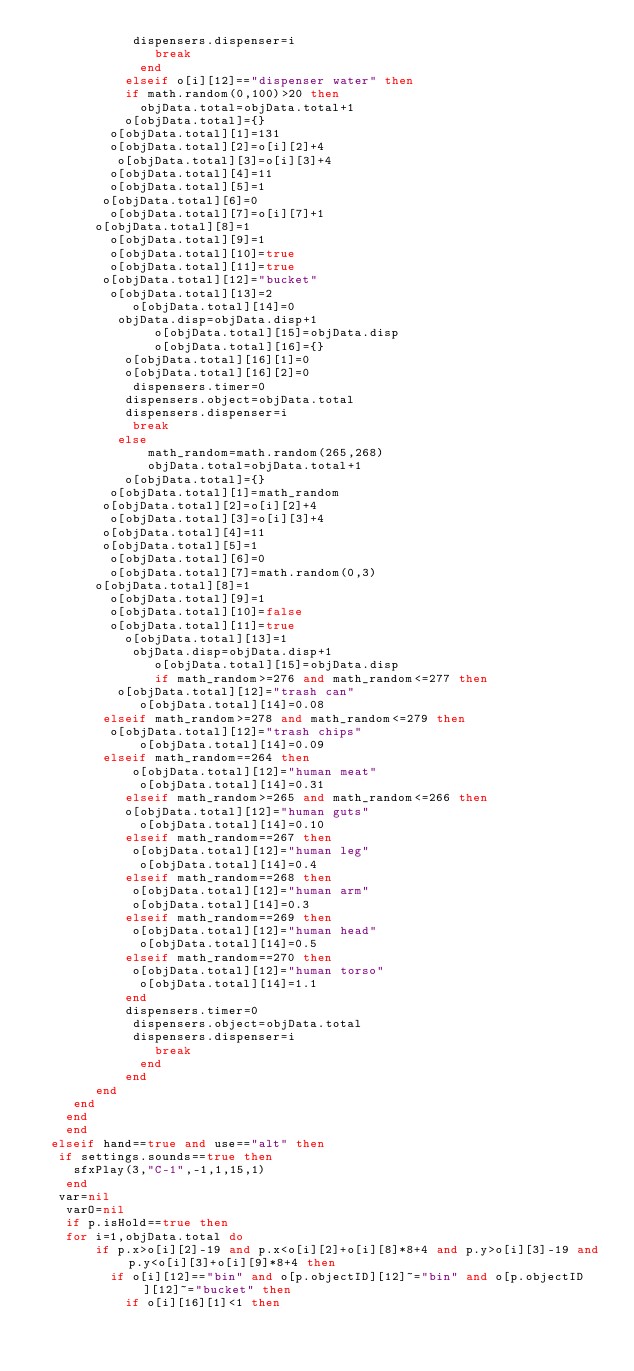<code> <loc_0><loc_0><loc_500><loc_500><_Lua_> 						 dispensers.dispenser=i
								break
							end
						elseif o[i][12]=="dispenser water" then
				  	if math.random(0,100)>20 then
 							objData.total=objData.total+1
   					o[objData.total]={}
      		o[objData.total][1]=131
	      	o[objData.total][2]=o[i][2]+4
		    	 o[objData.total][3]=o[i][3]+4
   		  	o[objData.total][4]=11
	   		  o[objData.total][5]=1
 		     o[objData.total][6]=0
  	 		  o[objData.total][7]=o[i][7]+1
     	 	o[objData.total][8]=1
	     		o[objData.total][9]=1
		      o[objData.total][10]=true
 			    o[objData.total][11]=true
    	 	 o[objData.total][12]="bucket"
 	  		 	o[objData.total][13]=2
				  	 o[objData.total][14]=0
 	 				 objData.disp=objData.disp+1
								o[objData.total][15]=objData.disp
								o[objData.total][16]={}
		   			o[objData.total][16][1]=0
			 	  	o[objData.total][16][2]=0
				 		 dispensers.timer=0
  			 		dispensers.object=objData.total
		  		 	dispensers.dispenser=i
				  	 break
  				 else
							 math_random=math.random(265,268)
							 objData.total=objData.total+1
  	 				o[objData.total]={}
      		o[objData.total][1]=math_random
	   	 	 o[objData.total][2]=o[i][2]+4
		     	o[objData.total][3]=o[i][3]+4
   		 	 o[objData.total][4]=11
 	 		   o[objData.total][5]=1
  	  	  o[objData.total][6]=0
 	  		  o[objData.total][7]=math.random(0,3)
     	 	o[objData.total][8]=1
	     		o[objData.total][9]=1
		      o[objData.total][10]=false
 			    o[objData.total][11]=true
  	  			o[objData.total][13]=1
	  				 objData.disp=objData.disp+1
								o[objData.total][15]=objData.disp
								if math_random>=276 and math_random<=277 then
    		   o[objData.total][12]="trash can"
				    	o[objData.total][14]=0.08
     		 elseif math_random>=278 and math_random<=279 then
	 	      o[objData.total][12]="trash chips"
    					o[objData.total][14]=0.09
 		     elseif math_random==264 then
    				 o[objData.total][12]="human meat"
				    	o[objData.total][14]=0.31
    				elseif math_random>=265 and math_random<=266 then
	 			    o[objData.total][12]="human guts"
    					o[objData.total][14]=0.10
				    elseif math_random==267 then
    				 o[objData.total][12]="human leg"
				    	o[objData.total][14]=0.4
    				elseif math_random==268 then
				     o[objData.total][12]="human arm"
    				 o[objData.total][14]=0.3
				    elseif math_random==269 then
    				 o[objData.total][12]="human head"
				    	o[objData.total][14]=0.5
    				elseif math_random==270 then
				     o[objData.total][12]="human torso"
    					o[objData.total][14]=1.1
			    	end
		  		 	dispensers.timer=0
				  	 dispensers.object=objData.total
 						 dispensers.dispenser=i
								break
							end
						end
		  	end
  	 end
	  end
		end
	elseif hand==true and use=="alt" then
	 if settings.sounds==true then
		 sfxPlay(3,"C-1",-1,1,15,1)
		end
	 var=nil
		varO=nil
		if p.isHold==true then
 		for i=1,objData.total do
				if p.x>o[i][2]-19 and p.x<o[i][2]+o[i][8]*8+4 and p.y>o[i][3]-19 and p.y<o[i][3]+o[i][9]*8+4 then
					if o[i][12]=="bin" and o[p.objectID][12]~="bin" and o[p.objectID][12]~="bucket" then
						if o[i][16][1]<1 then</code> 